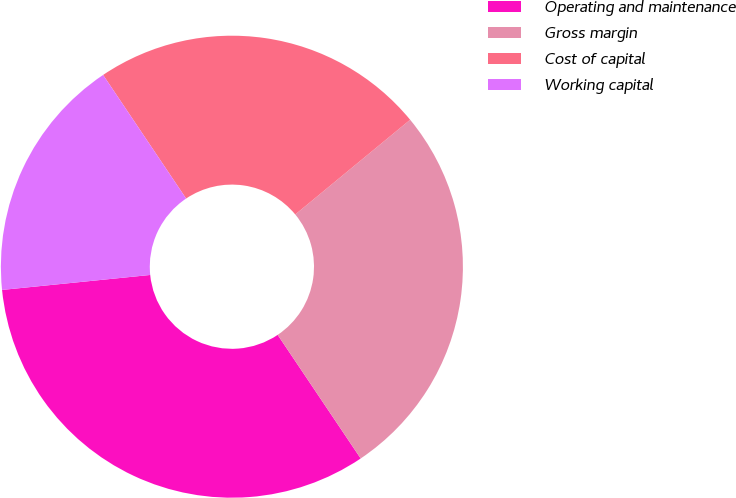Convert chart. <chart><loc_0><loc_0><loc_500><loc_500><pie_chart><fcel>Operating and maintenance<fcel>Gross margin<fcel>Cost of capital<fcel>Working capital<nl><fcel>32.81%<fcel>26.56%<fcel>23.44%<fcel>17.19%<nl></chart> 